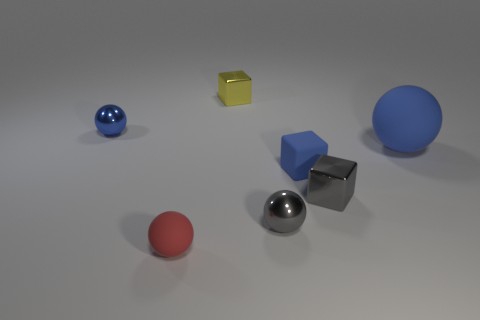Are there any other things that are the same size as the blue rubber sphere?
Your answer should be compact. No. What is the shape of the yellow metallic object on the right side of the metallic sphere behind the big thing?
Keep it short and to the point. Cube. There is a shiny ball that is right of the small matte sphere; what is its size?
Your answer should be compact. Small. Is the material of the small red thing the same as the tiny yellow thing?
Make the answer very short. No. What shape is the other red thing that is made of the same material as the big object?
Provide a succinct answer. Sphere. Is there anything else that has the same color as the tiny rubber sphere?
Your answer should be very brief. No. What is the color of the tiny shiny block in front of the small yellow metallic cube?
Make the answer very short. Gray. Is the color of the small shiny sphere that is behind the blue block the same as the big ball?
Provide a short and direct response. Yes. There is another blue thing that is the same shape as the small blue metal object; what is it made of?
Give a very brief answer. Rubber. How many matte things have the same size as the blue metallic object?
Provide a short and direct response. 2. 